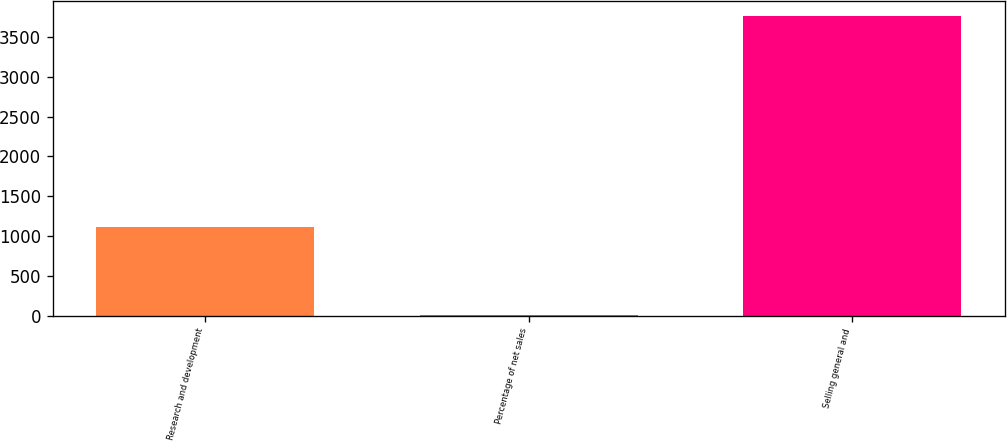Convert chart. <chart><loc_0><loc_0><loc_500><loc_500><bar_chart><fcel>Research and development<fcel>Percentage of net sales<fcel>Selling general and<nl><fcel>1109<fcel>3.4<fcel>3761<nl></chart> 